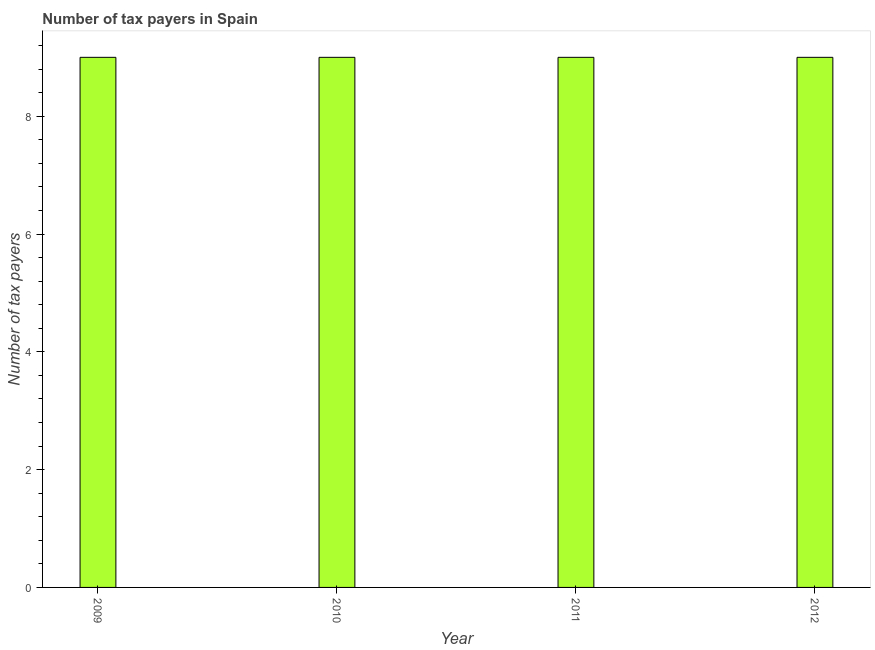Does the graph contain any zero values?
Your response must be concise. No. What is the title of the graph?
Provide a succinct answer. Number of tax payers in Spain. What is the label or title of the X-axis?
Make the answer very short. Year. What is the label or title of the Y-axis?
Your response must be concise. Number of tax payers. What is the number of tax payers in 2011?
Keep it short and to the point. 9. Across all years, what is the maximum number of tax payers?
Keep it short and to the point. 9. In which year was the number of tax payers maximum?
Offer a very short reply. 2009. What is the difference between the number of tax payers in 2009 and 2012?
Your answer should be compact. 0. Do a majority of the years between 2009 and 2011 (inclusive) have number of tax payers greater than 7.6 ?
Offer a terse response. Yes. Is the difference between the number of tax payers in 2009 and 2012 greater than the difference between any two years?
Offer a terse response. Yes. What is the difference between the highest and the second highest number of tax payers?
Offer a very short reply. 0. In how many years, is the number of tax payers greater than the average number of tax payers taken over all years?
Provide a short and direct response. 0. How many years are there in the graph?
Provide a succinct answer. 4. What is the difference between two consecutive major ticks on the Y-axis?
Give a very brief answer. 2. Are the values on the major ticks of Y-axis written in scientific E-notation?
Your answer should be very brief. No. What is the Number of tax payers in 2010?
Provide a short and direct response. 9. What is the Number of tax payers in 2011?
Offer a terse response. 9. What is the Number of tax payers in 2012?
Your answer should be compact. 9. What is the difference between the Number of tax payers in 2009 and 2010?
Your answer should be very brief. 0. What is the difference between the Number of tax payers in 2010 and 2011?
Your answer should be very brief. 0. What is the difference between the Number of tax payers in 2011 and 2012?
Give a very brief answer. 0. What is the ratio of the Number of tax payers in 2010 to that in 2011?
Provide a short and direct response. 1. What is the ratio of the Number of tax payers in 2010 to that in 2012?
Ensure brevity in your answer.  1. What is the ratio of the Number of tax payers in 2011 to that in 2012?
Ensure brevity in your answer.  1. 